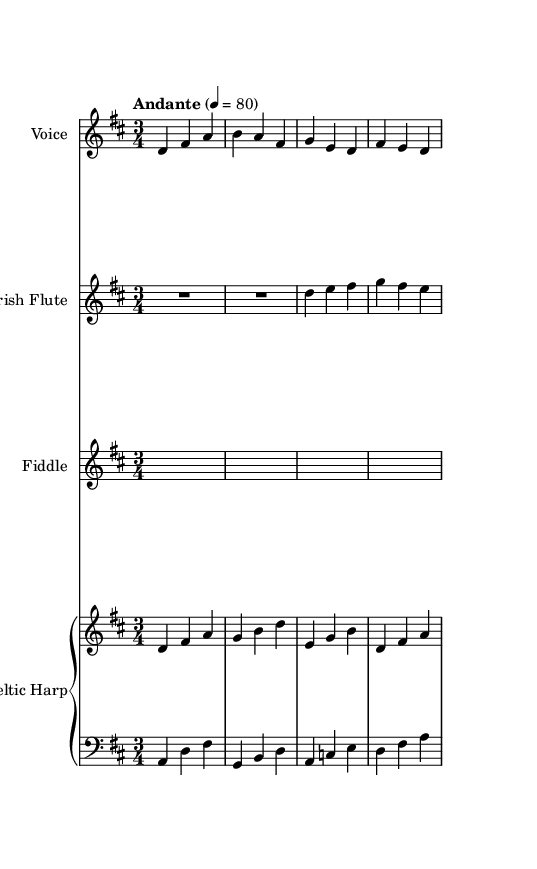What is the key signature of this music? The key signature is D major, as indicated by the two sharps (F# and C#) in the notation.
Answer: D major What is the time signature of this music? The time signature is 3/4, which is indicated at the beginning of the score with the notation "3/4." This means each measure contains three beats, and each quarter note gets one beat.
Answer: 3/4 What is the tempo marking for this piece? The tempo marking is "Andante," which typically indicates a moderately slow tempo, roughly between 76 and 108 beats per minute. This is further specified in the music with "4 = 80," meaning there are 80 beats per minute.
Answer: Andante How many instruments are specified in this score? There are five instruments indicated: Voice, Irish Flute, Fiddle, and two parts for the Celtic Harp (one treble and one bass).
Answer: Five What lyrical theme is conveyed in the text? The lyrics reference a sacred light shining through mist and rain, which suggests a spiritual or religious theme, common in Celtic hymns and folk songs.
Answer: Sacred light What form does the harp part take in the arrangement? The harp part is divided into two staves: one for the upper range (harpUp) and one for the lower range (harpDown), which creates a fuller sound in the arrangement.
Answer: Two staves Which element reflects the traditional Celtic musical style? The use of a 3/4 time signature is characteristic of Celtic music, often giving it a waltz-like flow, which is evident in this piece.
Answer: 3/4 time signature 